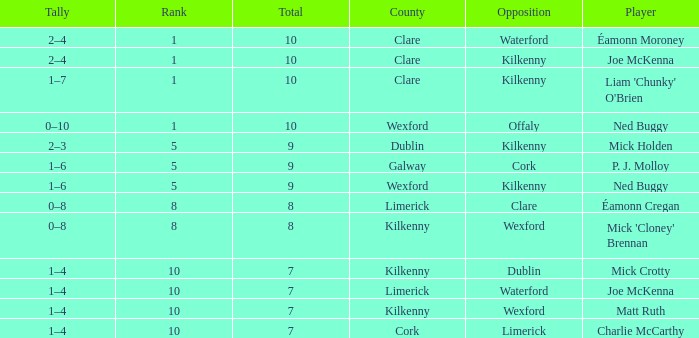Which Total has a County of kilkenny, and a Tally of 1–4, and a Rank larger than 10? None. 